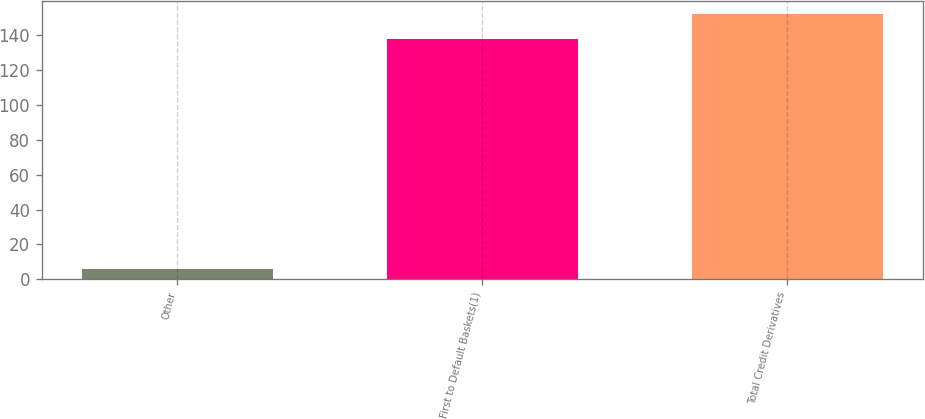Convert chart to OTSL. <chart><loc_0><loc_0><loc_500><loc_500><bar_chart><fcel>Other<fcel>First to Default Baskets(1)<fcel>Total Credit Derivatives<nl><fcel>6<fcel>138<fcel>152.2<nl></chart> 